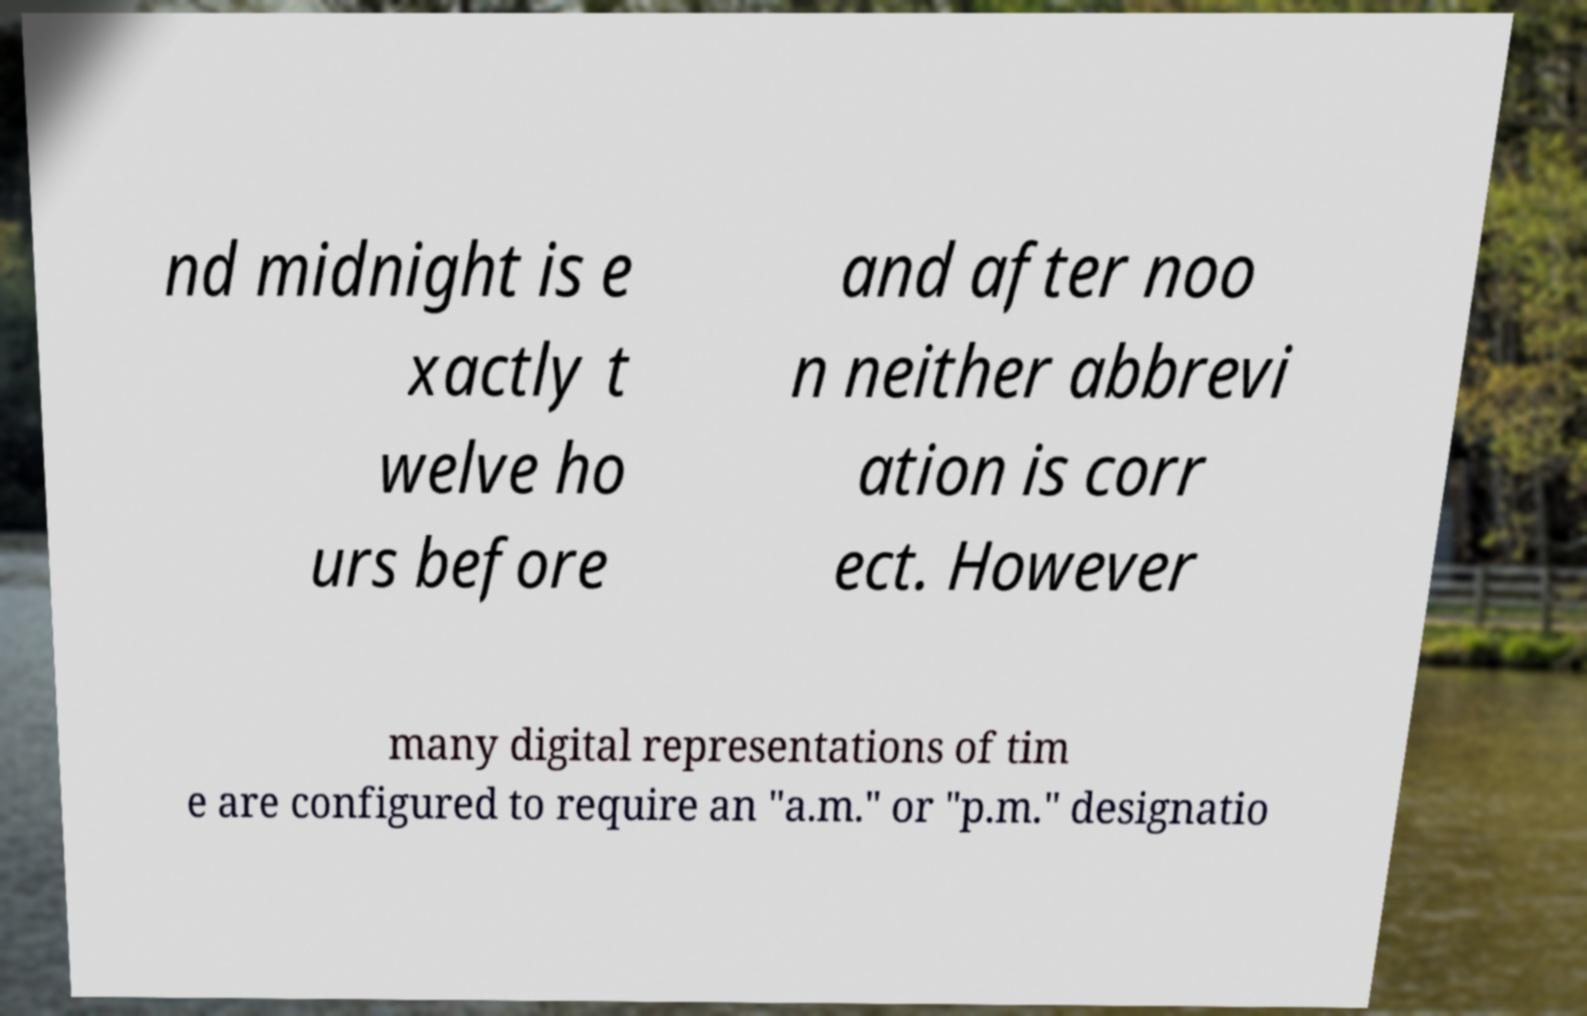Could you assist in decoding the text presented in this image and type it out clearly? nd midnight is e xactly t welve ho urs before and after noo n neither abbrevi ation is corr ect. However many digital representations of tim e are configured to require an "a.m." or "p.m." designatio 